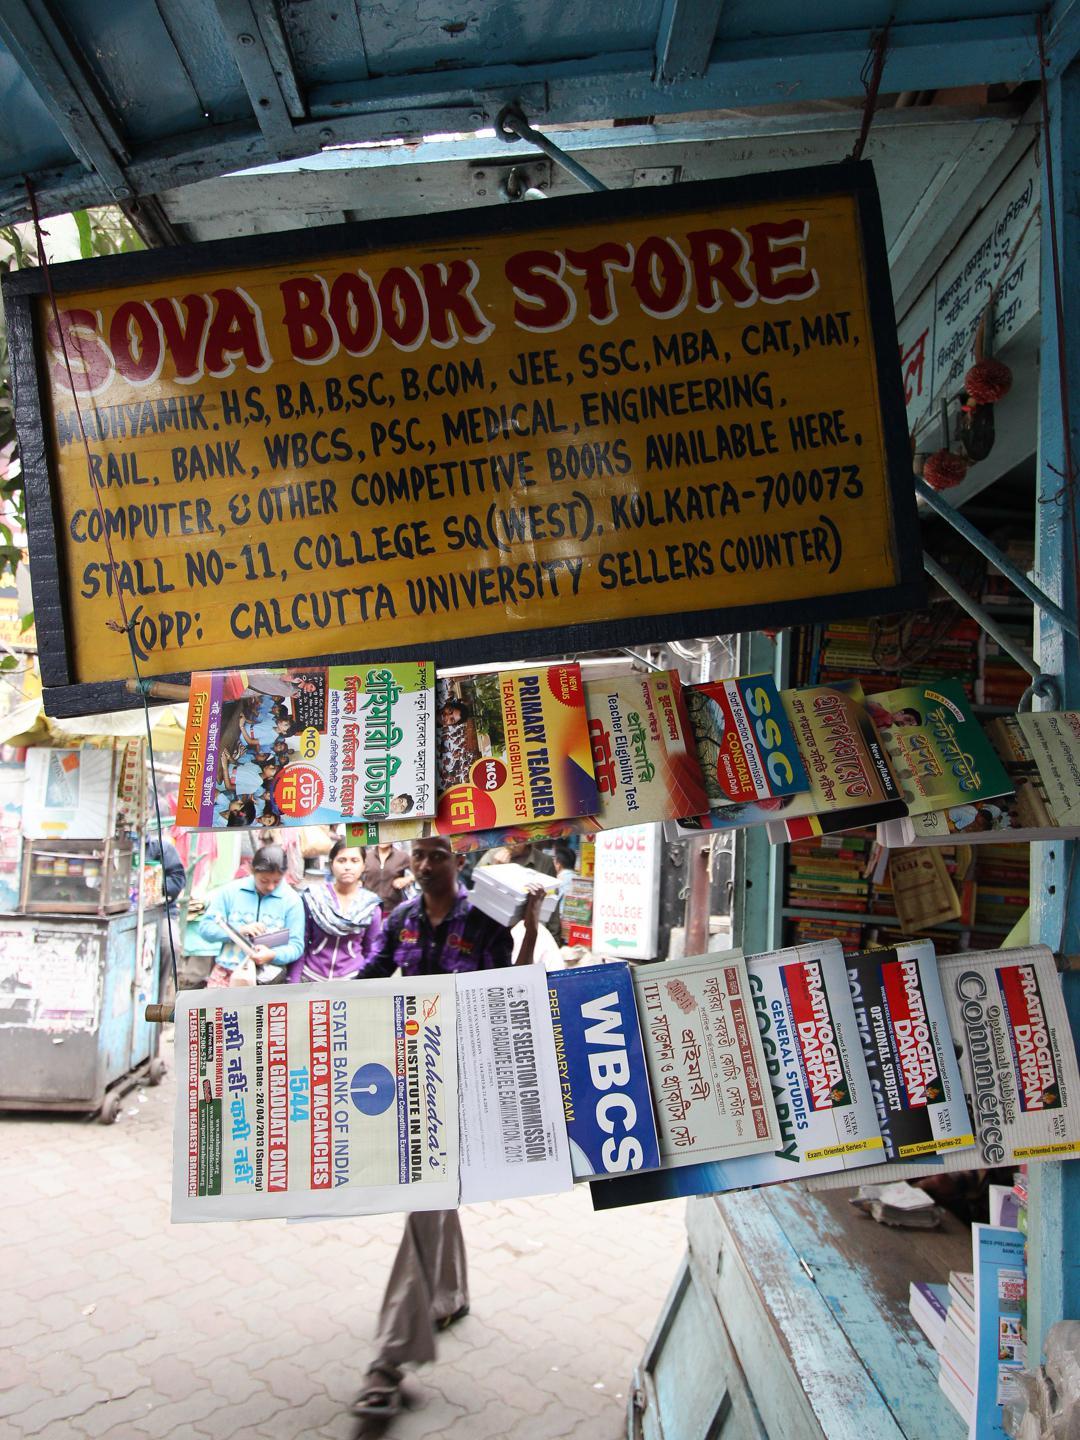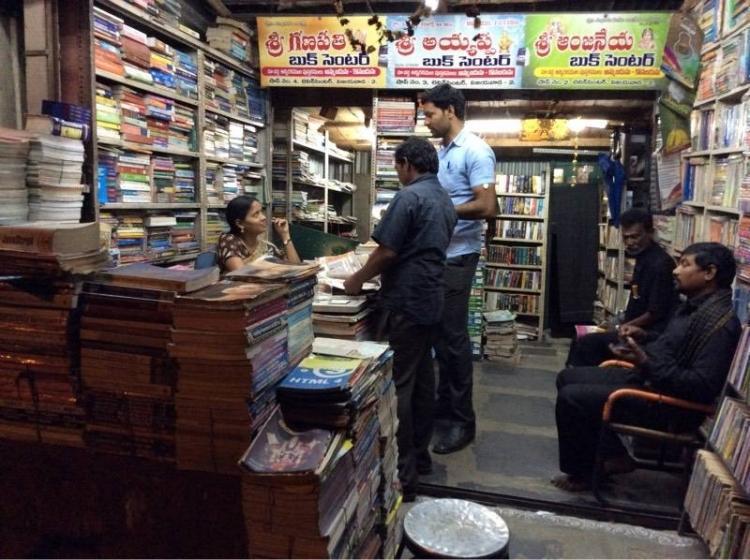The first image is the image on the left, the second image is the image on the right. Given the left and right images, does the statement "An image shows multiple people milling around near a store entrance that features red signage." hold true? Answer yes or no. No. The first image is the image on the left, the second image is the image on the right. Considering the images on both sides, is "There are more than half a dozen people standing around in the image on the left." valid? Answer yes or no. No. 